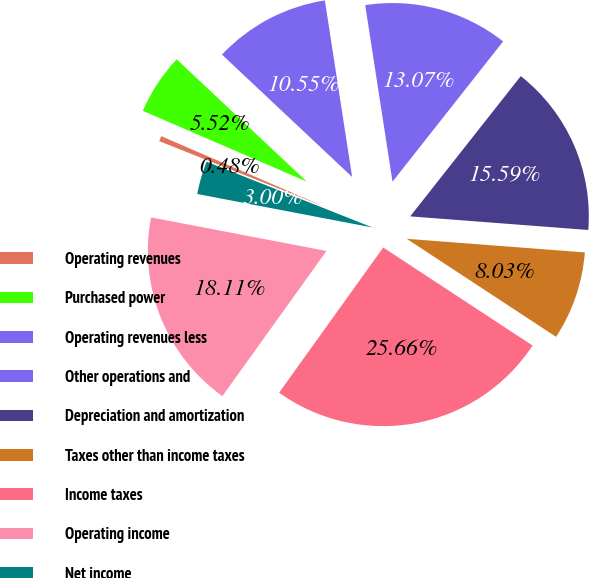<chart> <loc_0><loc_0><loc_500><loc_500><pie_chart><fcel>Operating revenues<fcel>Purchased power<fcel>Operating revenues less<fcel>Other operations and<fcel>Depreciation and amortization<fcel>Taxes other than income taxes<fcel>Income taxes<fcel>Operating income<fcel>Net income<nl><fcel>0.48%<fcel>5.52%<fcel>10.55%<fcel>13.07%<fcel>15.59%<fcel>8.03%<fcel>25.66%<fcel>18.11%<fcel>3.0%<nl></chart> 